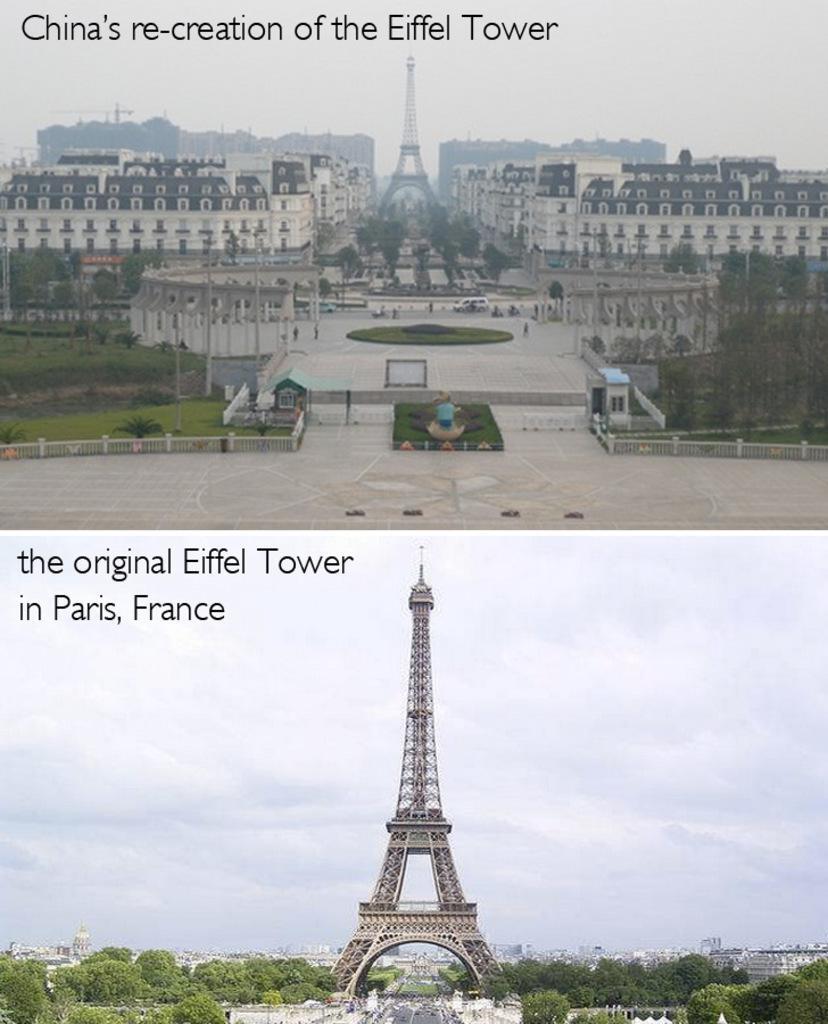In one or two sentences, can you explain what this image depicts? At the top of the image there is a tower. And also there are buildings, trees, poles and on the ground there is grass. At the bottom of the image there is an Eiffel tower and also there are trees. 